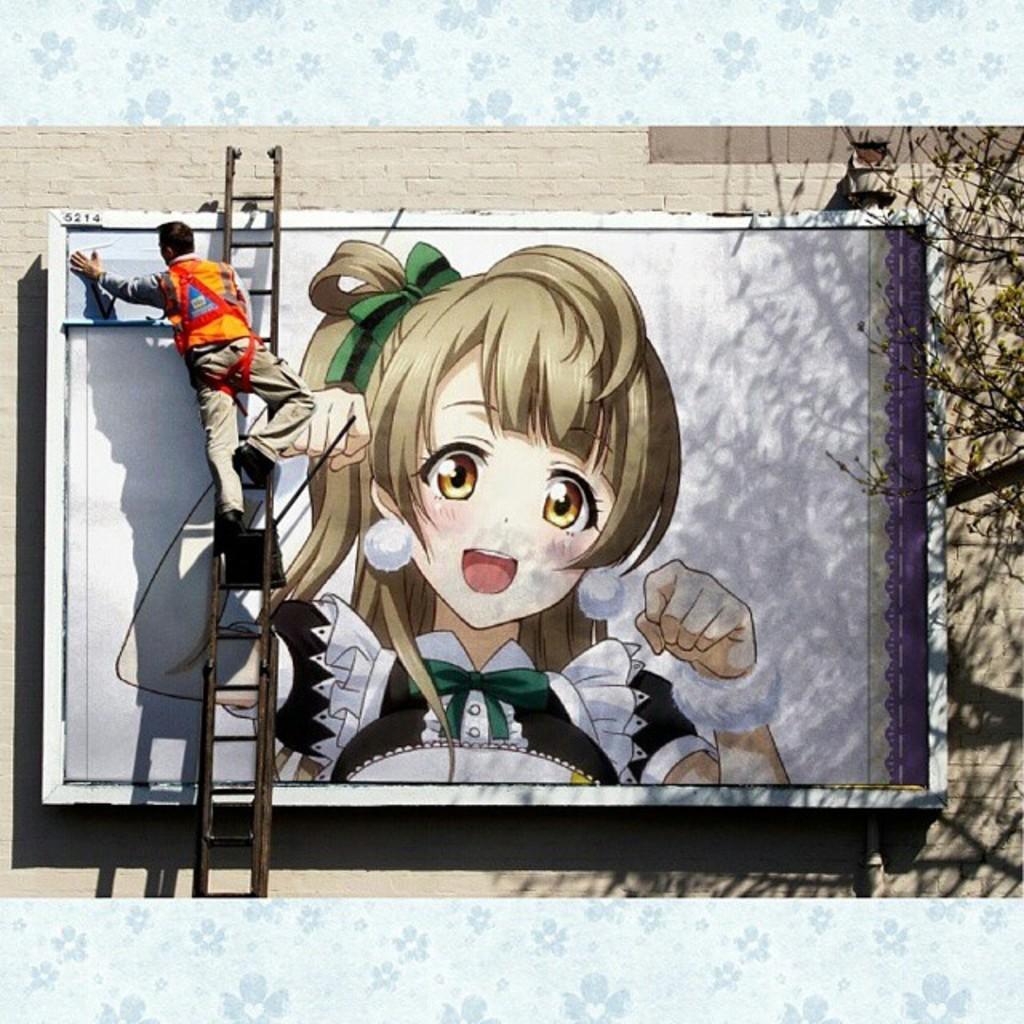In one or two sentences, can you explain what this image depicts? On the left side a man is painting by standing on the ladder, on the right side it is an art of a girl. 